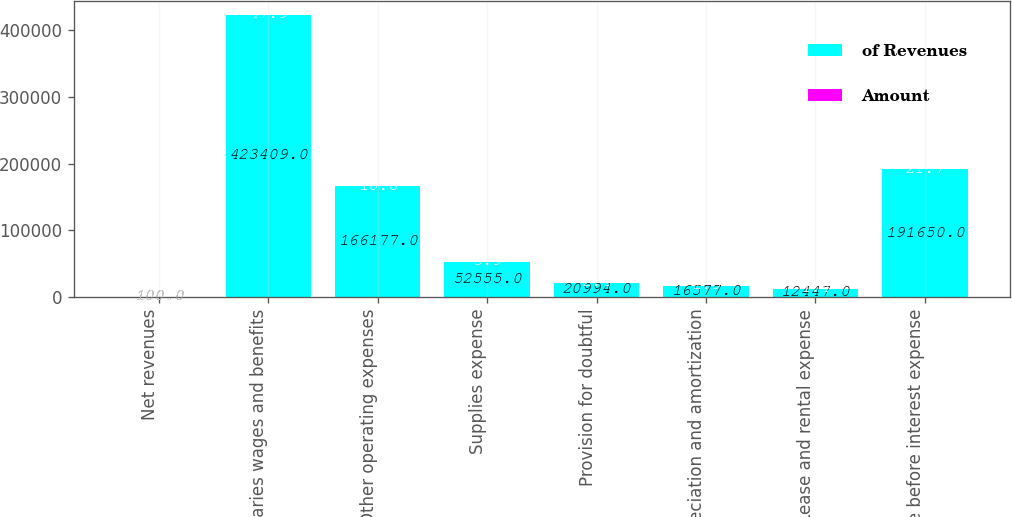Convert chart. <chart><loc_0><loc_0><loc_500><loc_500><stacked_bar_chart><ecel><fcel>Net revenues<fcel>Salaries wages and benefits<fcel>Other operating expenses<fcel>Supplies expense<fcel>Provision for doubtful<fcel>Depreciation and amortization<fcel>Lease and rental expense<fcel>Income before interest expense<nl><fcel>of Revenues<fcel>100<fcel>423409<fcel>166177<fcel>52555<fcel>20994<fcel>16577<fcel>12447<fcel>191650<nl><fcel>Amount<fcel>100<fcel>47.9<fcel>18.8<fcel>5.9<fcel>2.4<fcel>1.9<fcel>1.4<fcel>21.7<nl></chart> 